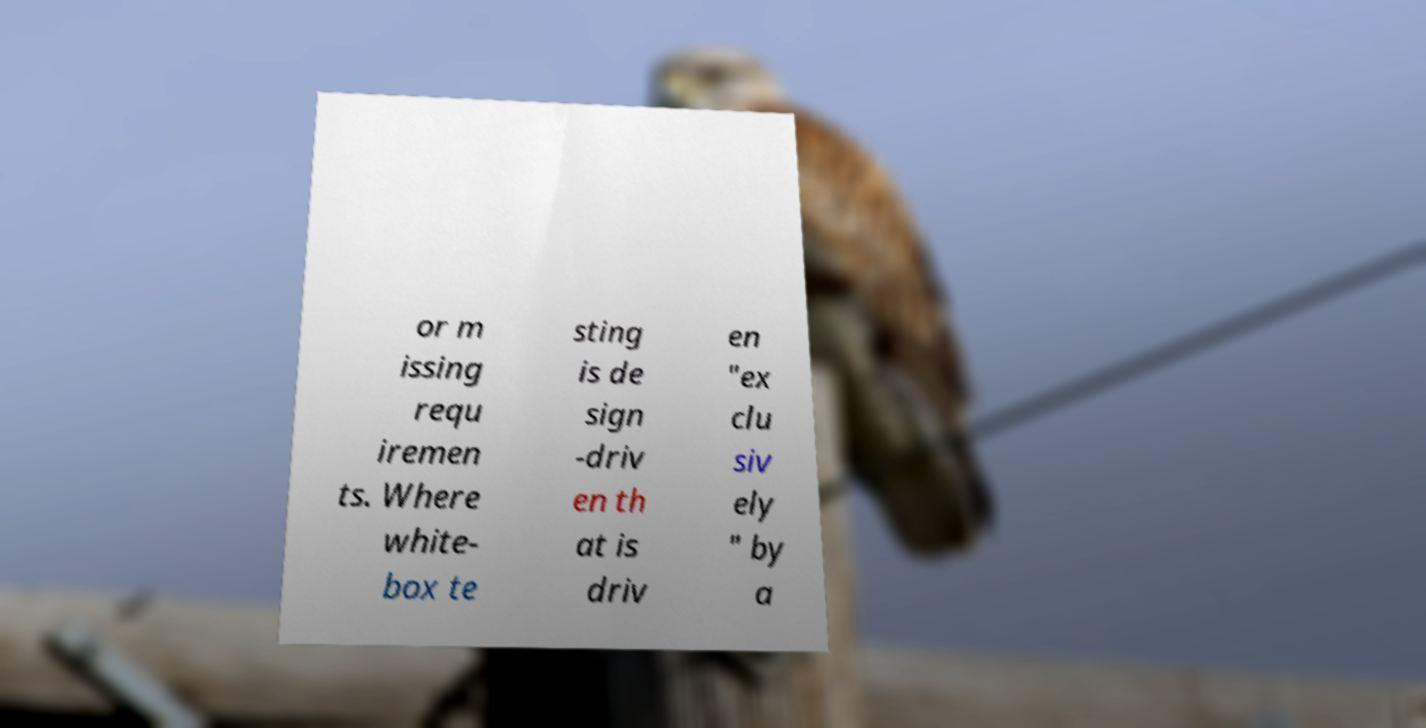There's text embedded in this image that I need extracted. Can you transcribe it verbatim? or m issing requ iremen ts. Where white- box te sting is de sign -driv en th at is driv en "ex clu siv ely " by a 